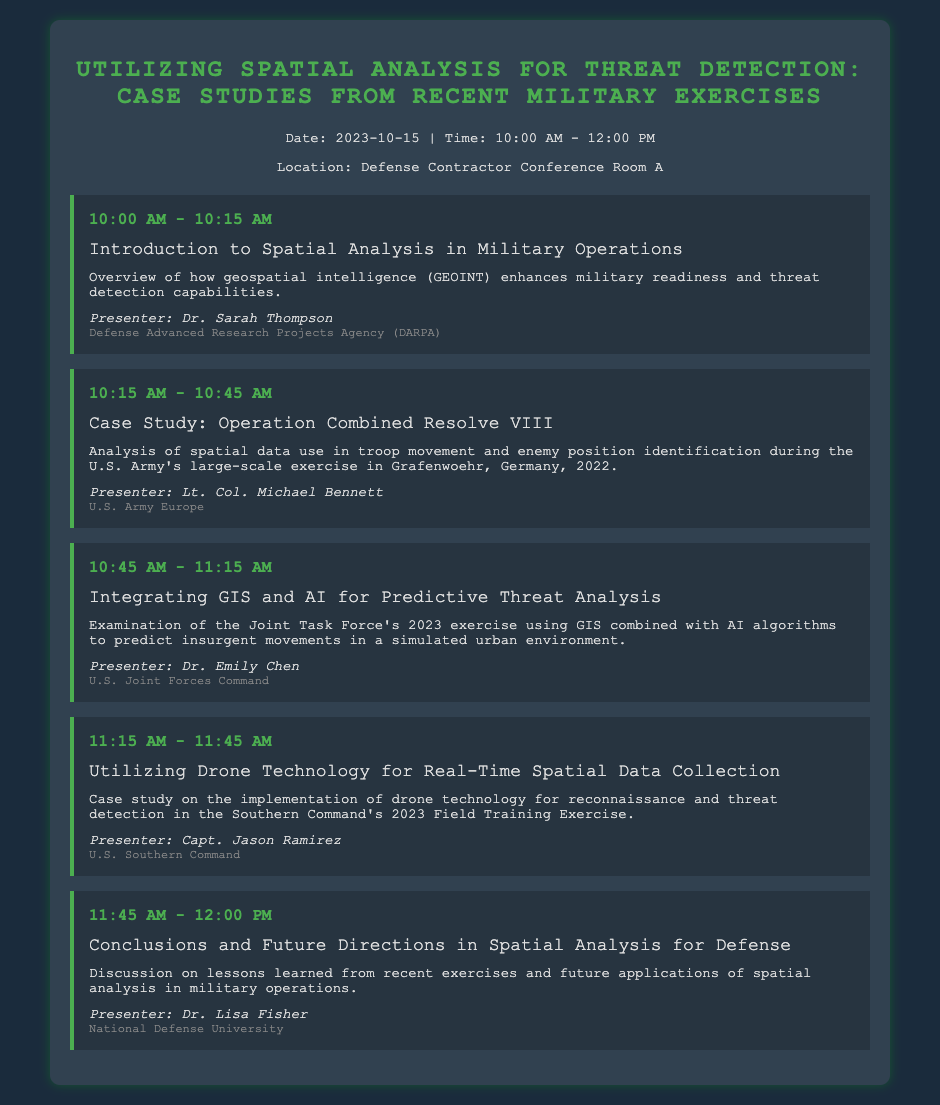What is the date of the agenda? The date is explicitly mentioned in the document as 2023-10-15.
Answer: 2023-10-15 Who is the presenter for the introduction session? The document lists Dr. Sarah Thompson as the presenter for the introduction.
Answer: Dr. Sarah Thompson What organization does Lt. Col. Michael Bennett represent? The agenda mentions that Lt. Col. Michael Bennett is from U.S. Army Europe.
Answer: U.S. Army Europe What time does the session on drone technology start? The agenda specifies that the session on drone technology starts at 11:15 AM.
Answer: 11:15 AM How long is the presentation on integrating GIS and AI? The duration for the presentation on integrating GIS and AI is 30 minutes, from 10:45 AM to 11:15 AM.
Answer: 30 minutes What case study focuses on troop movement analysis? The agenda identifies the case study on Operation Combined Resolve VIII as focusing on troop movement analysis.
Answer: Operation Combined Resolve VIII Who is presenting the conclusions and future directions session? Dr. Lisa Fisher is indicated as the presenter for the conclusions and future directions session.
Answer: Dr. Lisa Fisher What is the main topic of Dr. Emily Chen's presentation? Dr. Emily Chen's presentation is focused on GIS and AI for predictive threat analysis.
Answer: Predictive Threat Analysis 